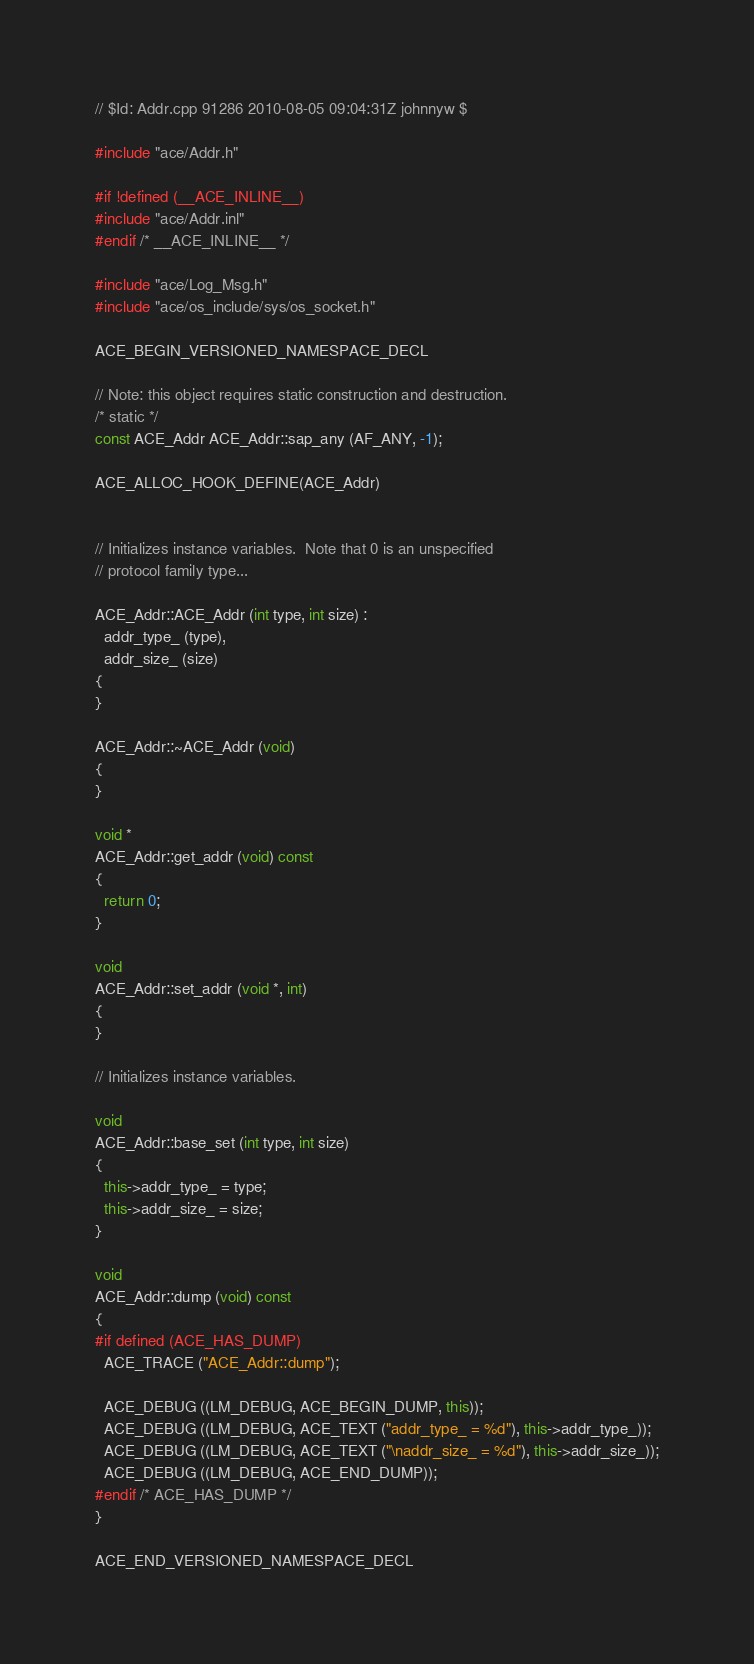<code> <loc_0><loc_0><loc_500><loc_500><_C++_>// $Id: Addr.cpp 91286 2010-08-05 09:04:31Z johnnyw $

#include "ace/Addr.h"

#if !defined (__ACE_INLINE__)
#include "ace/Addr.inl"
#endif /* __ACE_INLINE__ */

#include "ace/Log_Msg.h"
#include "ace/os_include/sys/os_socket.h"

ACE_BEGIN_VERSIONED_NAMESPACE_DECL

// Note: this object requires static construction and destruction.
/* static */
const ACE_Addr ACE_Addr::sap_any (AF_ANY, -1);

ACE_ALLOC_HOOK_DEFINE(ACE_Addr)


// Initializes instance variables.  Note that 0 is an unspecified
// protocol family type...

ACE_Addr::ACE_Addr (int type, int size) :
  addr_type_ (type),
  addr_size_ (size)
{
}

ACE_Addr::~ACE_Addr (void)
{
}

void *
ACE_Addr::get_addr (void) const
{
  return 0;
}

void
ACE_Addr::set_addr (void *, int)
{
}

// Initializes instance variables.

void
ACE_Addr::base_set (int type, int size)
{
  this->addr_type_ = type;
  this->addr_size_ = size;
}

void
ACE_Addr::dump (void) const
{
#if defined (ACE_HAS_DUMP)
  ACE_TRACE ("ACE_Addr::dump");

  ACE_DEBUG ((LM_DEBUG, ACE_BEGIN_DUMP, this));
  ACE_DEBUG ((LM_DEBUG, ACE_TEXT ("addr_type_ = %d"), this->addr_type_));
  ACE_DEBUG ((LM_DEBUG, ACE_TEXT ("\naddr_size_ = %d"), this->addr_size_));
  ACE_DEBUG ((LM_DEBUG, ACE_END_DUMP));
#endif /* ACE_HAS_DUMP */
}

ACE_END_VERSIONED_NAMESPACE_DECL
</code> 